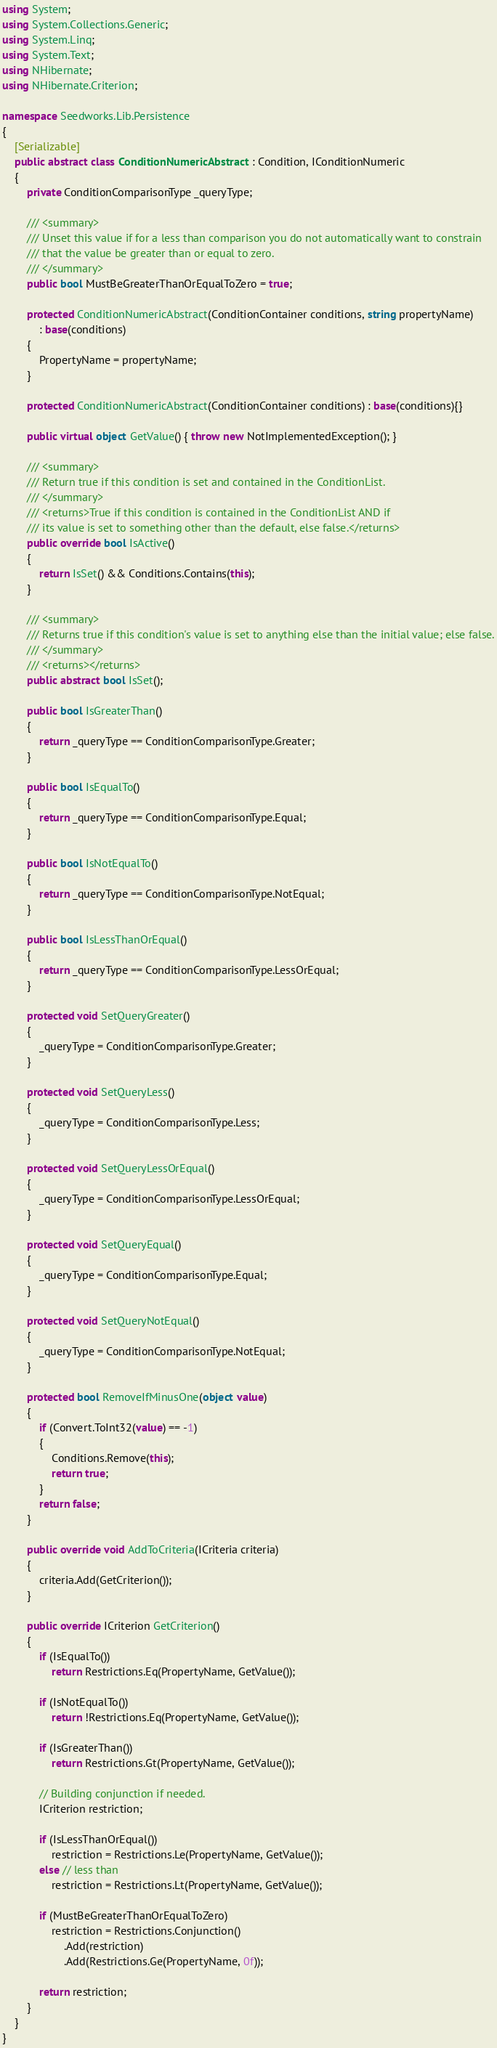Convert code to text. <code><loc_0><loc_0><loc_500><loc_500><_C#_>using System;
using System.Collections.Generic;
using System.Linq;
using System.Text;
using NHibernate;
using NHibernate.Criterion;

namespace Seedworks.Lib.Persistence
{
    [Serializable]
    public abstract class ConditionNumericAbstract : Condition, IConditionNumeric
    {
        private ConditionComparisonType _queryType;

        /// <summary>
        /// Unset this value if for a less than comparison you do not automatically want to constrain
        /// that the value be greater than or equal to zero.
        /// </summary>
        public bool MustBeGreaterThanOrEqualToZero = true;

        protected ConditionNumericAbstract(ConditionContainer conditions, string propertyName)
            : base(conditions)
        {
            PropertyName = propertyName;
        }

        protected ConditionNumericAbstract(ConditionContainer conditions) : base(conditions){}

        public virtual object GetValue() { throw new NotImplementedException(); }

        /// <summary>
        /// Return true if this condition is set and contained in the ConditionList.
        /// </summary>
        /// <returns>True if this condition is contained in the ConditionList AND if 
        /// its value is set to something other than the default, else false.</returns>
        public override bool IsActive()
        {
            return IsSet() && Conditions.Contains(this);
        }

        /// <summary>
        /// Returns true if this condition's value is set to anything else than the initial value; else false.
        /// </summary>
        /// <returns></returns>
        public abstract bool IsSet();

        public bool IsGreaterThan()
        {
            return _queryType == ConditionComparisonType.Greater;
        }

        public bool IsEqualTo()
        {
            return _queryType == ConditionComparisonType.Equal;
        }

        public bool IsNotEqualTo()
        {
            return _queryType == ConditionComparisonType.NotEqual;
        }

        public bool IsLessThanOrEqual()
        {
            return _queryType == ConditionComparisonType.LessOrEqual;
        }

        protected void SetQueryGreater()
        {
            _queryType = ConditionComparisonType.Greater;
        }

        protected void SetQueryLess()
        {
            _queryType = ConditionComparisonType.Less;
        }

        protected void SetQueryLessOrEqual()
        {
            _queryType = ConditionComparisonType.LessOrEqual;
        }

        protected void SetQueryEqual()
        {
            _queryType = ConditionComparisonType.Equal;
        }

        protected void SetQueryNotEqual()
        {
            _queryType = ConditionComparisonType.NotEqual;
        }

        protected bool RemoveIfMinusOne(object value)
        {
            if (Convert.ToInt32(value) == -1)
            {
                Conditions.Remove(this);
                return true;
            }
            return false;
        }

        public override void AddToCriteria(ICriteria criteria)
        {
            criteria.Add(GetCriterion());
        }

        public override ICriterion GetCriterion()
        {
            if (IsEqualTo())
                return Restrictions.Eq(PropertyName, GetValue());

            if (IsNotEqualTo())
                return !Restrictions.Eq(PropertyName, GetValue());
            
            if (IsGreaterThan())
                return Restrictions.Gt(PropertyName, GetValue());
            
            // Building conjunction if needed.
            ICriterion restriction;

            if (IsLessThanOrEqual())
                restriction = Restrictions.Le(PropertyName, GetValue());
            else // less than
                restriction = Restrictions.Lt(PropertyName, GetValue());

            if (MustBeGreaterThanOrEqualToZero)
                restriction = Restrictions.Conjunction()
                    .Add(restriction)
                    .Add(Restrictions.Ge(PropertyName, 0f));

            return restriction;
        }
    }
}
</code> 